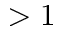Convert formula to latex. <formula><loc_0><loc_0><loc_500><loc_500>> 1</formula> 